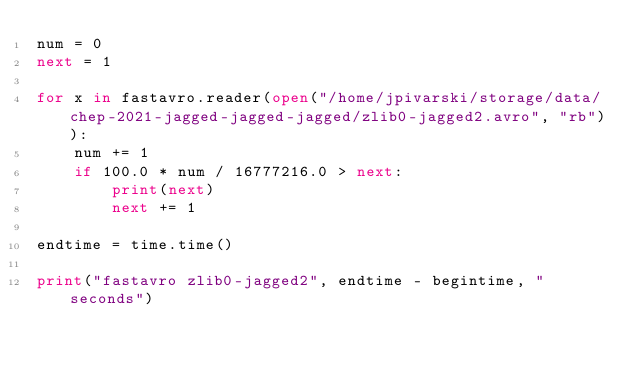<code> <loc_0><loc_0><loc_500><loc_500><_Python_>num = 0
next = 1

for x in fastavro.reader(open("/home/jpivarski/storage/data/chep-2021-jagged-jagged-jagged/zlib0-jagged2.avro", "rb")):
    num += 1
    if 100.0 * num / 16777216.0 > next:
        print(next)
        next += 1

endtime = time.time()

print("fastavro zlib0-jagged2", endtime - begintime, "seconds")
</code> 